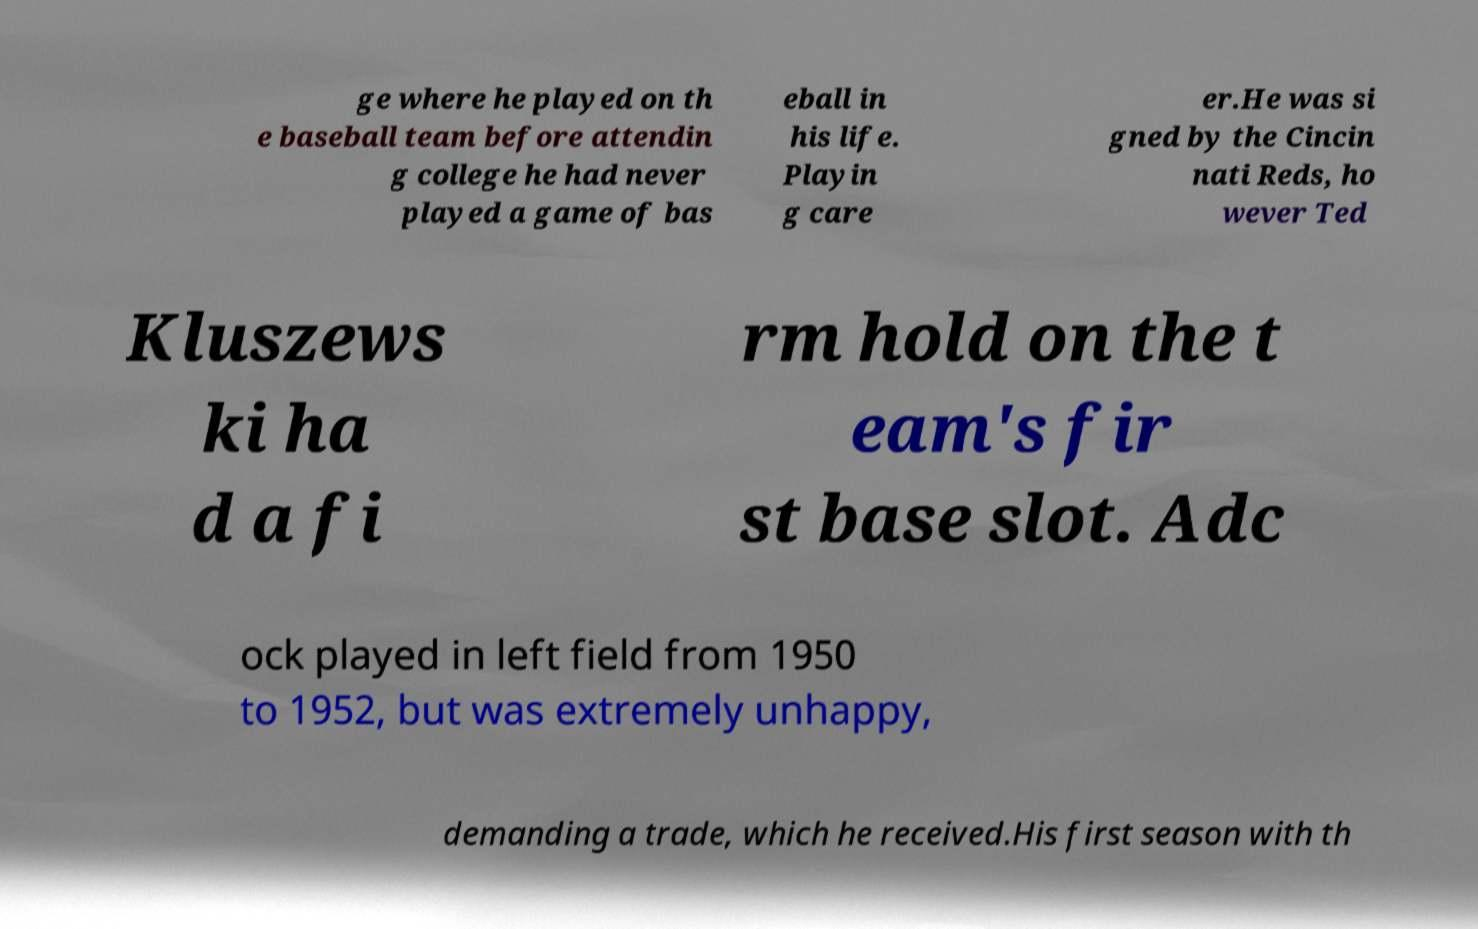Can you read and provide the text displayed in the image?This photo seems to have some interesting text. Can you extract and type it out for me? ge where he played on th e baseball team before attendin g college he had never played a game of bas eball in his life. Playin g care er.He was si gned by the Cincin nati Reds, ho wever Ted Kluszews ki ha d a fi rm hold on the t eam's fir st base slot. Adc ock played in left field from 1950 to 1952, but was extremely unhappy, demanding a trade, which he received.His first season with th 